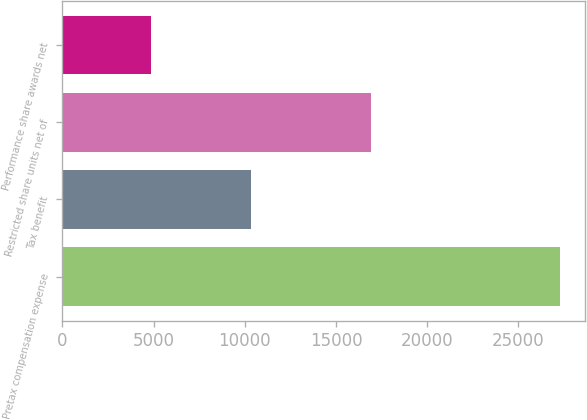<chart> <loc_0><loc_0><loc_500><loc_500><bar_chart><fcel>Pretax compensation expense<fcel>Tax benefit<fcel>Restricted share units net of<fcel>Performance share awards net<nl><fcel>27256<fcel>10360<fcel>16896<fcel>4886<nl></chart> 